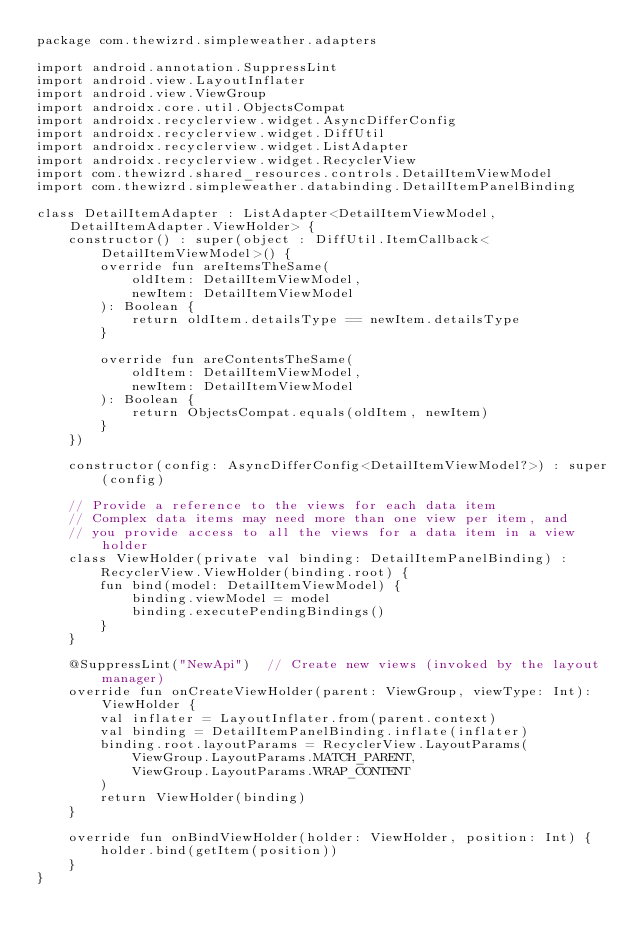Convert code to text. <code><loc_0><loc_0><loc_500><loc_500><_Kotlin_>package com.thewizrd.simpleweather.adapters

import android.annotation.SuppressLint
import android.view.LayoutInflater
import android.view.ViewGroup
import androidx.core.util.ObjectsCompat
import androidx.recyclerview.widget.AsyncDifferConfig
import androidx.recyclerview.widget.DiffUtil
import androidx.recyclerview.widget.ListAdapter
import androidx.recyclerview.widget.RecyclerView
import com.thewizrd.shared_resources.controls.DetailItemViewModel
import com.thewizrd.simpleweather.databinding.DetailItemPanelBinding

class DetailItemAdapter : ListAdapter<DetailItemViewModel, DetailItemAdapter.ViewHolder> {
    constructor() : super(object : DiffUtil.ItemCallback<DetailItemViewModel>() {
        override fun areItemsTheSame(
            oldItem: DetailItemViewModel,
            newItem: DetailItemViewModel
        ): Boolean {
            return oldItem.detailsType == newItem.detailsType
        }

        override fun areContentsTheSame(
            oldItem: DetailItemViewModel,
            newItem: DetailItemViewModel
        ): Boolean {
            return ObjectsCompat.equals(oldItem, newItem)
        }
    })

    constructor(config: AsyncDifferConfig<DetailItemViewModel?>) : super(config)

    // Provide a reference to the views for each data item
    // Complex data items may need more than one view per item, and
    // you provide access to all the views for a data item in a view holder
    class ViewHolder(private val binding: DetailItemPanelBinding) :
        RecyclerView.ViewHolder(binding.root) {
        fun bind(model: DetailItemViewModel) {
            binding.viewModel = model
            binding.executePendingBindings()
        }
    }

    @SuppressLint("NewApi")  // Create new views (invoked by the layout manager)
    override fun onCreateViewHolder(parent: ViewGroup, viewType: Int): ViewHolder {
        val inflater = LayoutInflater.from(parent.context)
        val binding = DetailItemPanelBinding.inflate(inflater)
        binding.root.layoutParams = RecyclerView.LayoutParams(
            ViewGroup.LayoutParams.MATCH_PARENT,
            ViewGroup.LayoutParams.WRAP_CONTENT
        )
        return ViewHolder(binding)
    }

    override fun onBindViewHolder(holder: ViewHolder, position: Int) {
        holder.bind(getItem(position))
    }
}</code> 